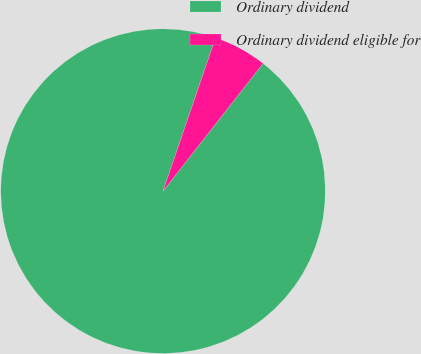Convert chart. <chart><loc_0><loc_0><loc_500><loc_500><pie_chart><fcel>Ordinary dividend<fcel>Ordinary dividend eligible for<nl><fcel>94.67%<fcel>5.33%<nl></chart> 